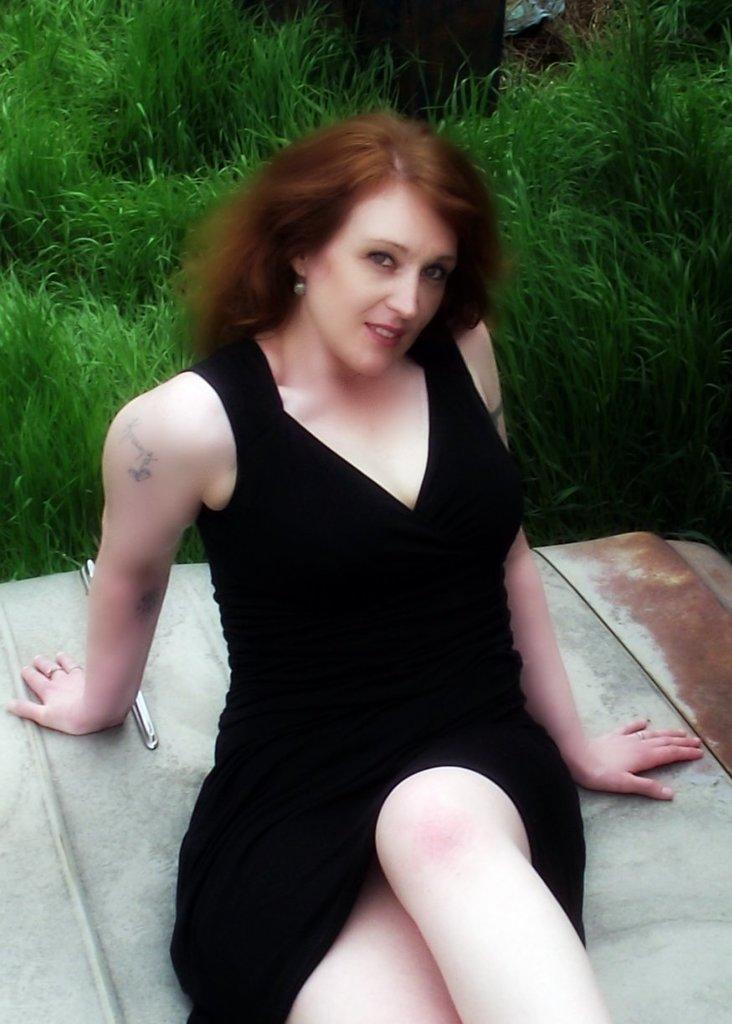Who is the main subject in the image? There is a woman in the image. What is the woman wearing? The woman is wearing a black top. Where is the woman located in the image? The woman is lying on a car bonnet. What is the woman's facial expression in the image? The woman is smiling. What is the woman doing in the image? The woman is posing for the camera. What can be seen in the background of the image? There is grass visible in the background of the image. What type of disease can be seen affecting the woman in the image? There is no disease present in the image; the woman appears healthy and smiling. What brand of soda is the woman holding in the image? There is no soda present in the image; the woman is lying on a car bonnet and posing for the camera. 